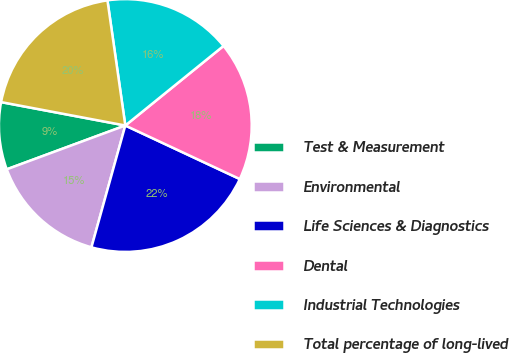<chart> <loc_0><loc_0><loc_500><loc_500><pie_chart><fcel>Test & Measurement<fcel>Environmental<fcel>Life Sciences & Diagnostics<fcel>Dental<fcel>Industrial Technologies<fcel>Total percentage of long-lived<nl><fcel>8.6%<fcel>15.05%<fcel>22.36%<fcel>17.8%<fcel>16.42%<fcel>19.78%<nl></chart> 